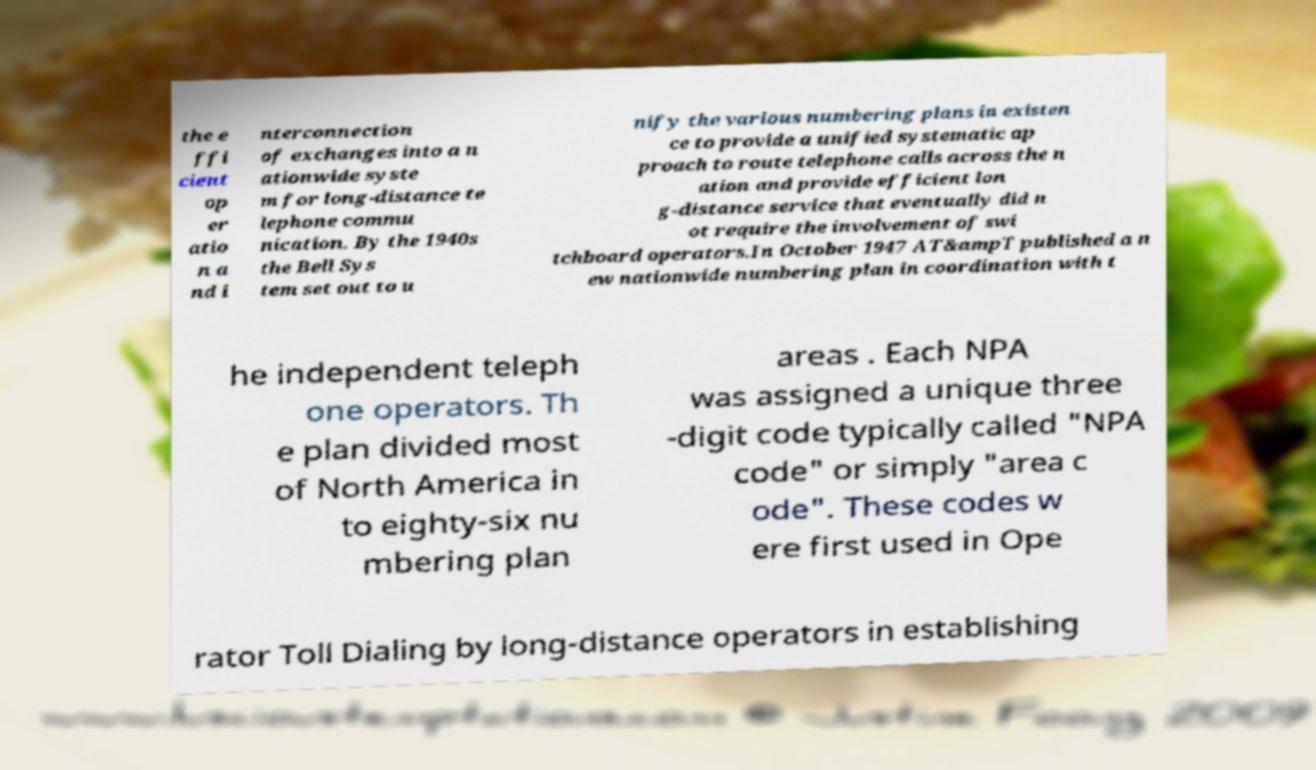Can you accurately transcribe the text from the provided image for me? the e ffi cient op er atio n a nd i nterconnection of exchanges into a n ationwide syste m for long-distance te lephone commu nication. By the 1940s the Bell Sys tem set out to u nify the various numbering plans in existen ce to provide a unified systematic ap proach to route telephone calls across the n ation and provide efficient lon g-distance service that eventually did n ot require the involvement of swi tchboard operators.In October 1947 AT&ampT published a n ew nationwide numbering plan in coordination with t he independent teleph one operators. Th e plan divided most of North America in to eighty-six nu mbering plan areas . Each NPA was assigned a unique three -digit code typically called "NPA code" or simply "area c ode". These codes w ere first used in Ope rator Toll Dialing by long-distance operators in establishing 